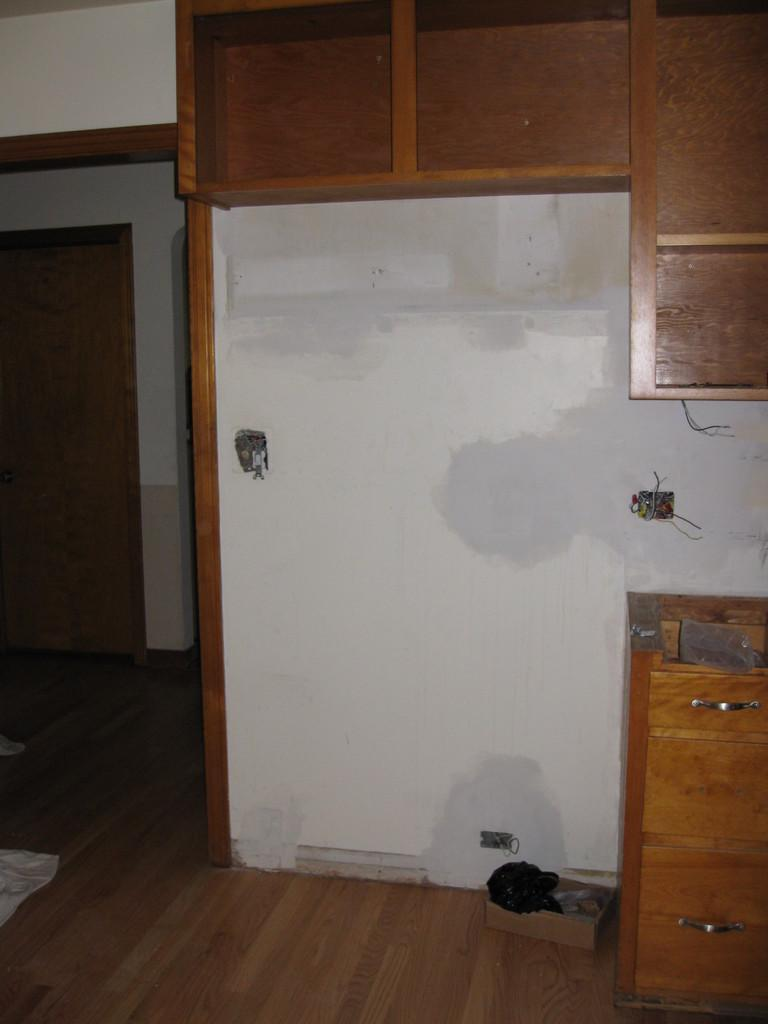What type of storage units are visible at the top of the image? There are wooden shelves at the top of the image. What type of storage units are visible at the bottom of the image? There are cupboards at the bottom of the image. Where is the entrance located in the image? The entrance is on the left side of the image. Can you see a stream of water flowing through the entrance in the image? There is no stream of water visible in the image; it only features wooden shelves, cupboards, and an entrance. How many women are present in the image? There are no women present in the image. 